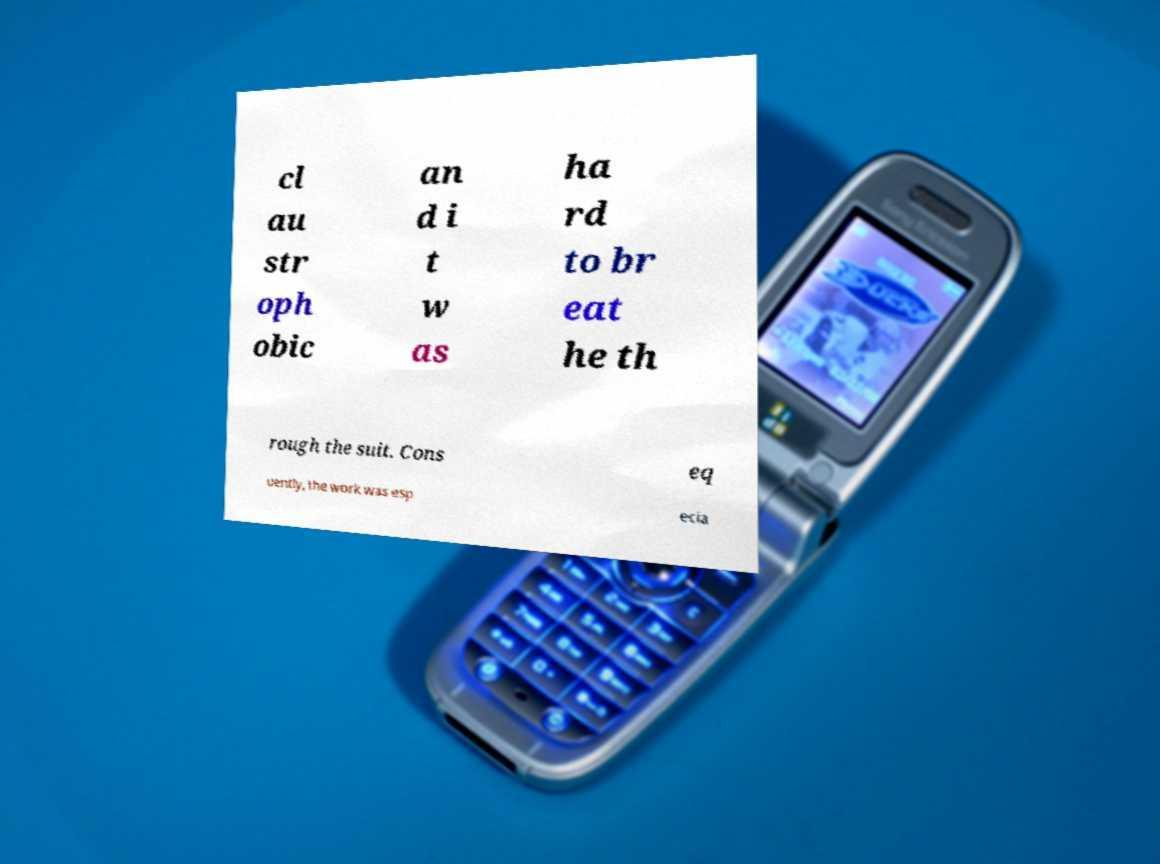Can you read and provide the text displayed in the image?This photo seems to have some interesting text. Can you extract and type it out for me? cl au str oph obic an d i t w as ha rd to br eat he th rough the suit. Cons eq uently, the work was esp ecia 